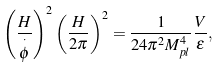<formula> <loc_0><loc_0><loc_500><loc_500>\left ( \frac { H } { \overset { \cdot } { \phi } } \right ) ^ { 2 } \left ( \frac { H } { 2 \pi } \right ) ^ { 2 } = \frac { 1 } { 2 4 \pi ^ { 2 } M _ { p l } ^ { 4 } } \frac { V } { \varepsilon } ,</formula> 